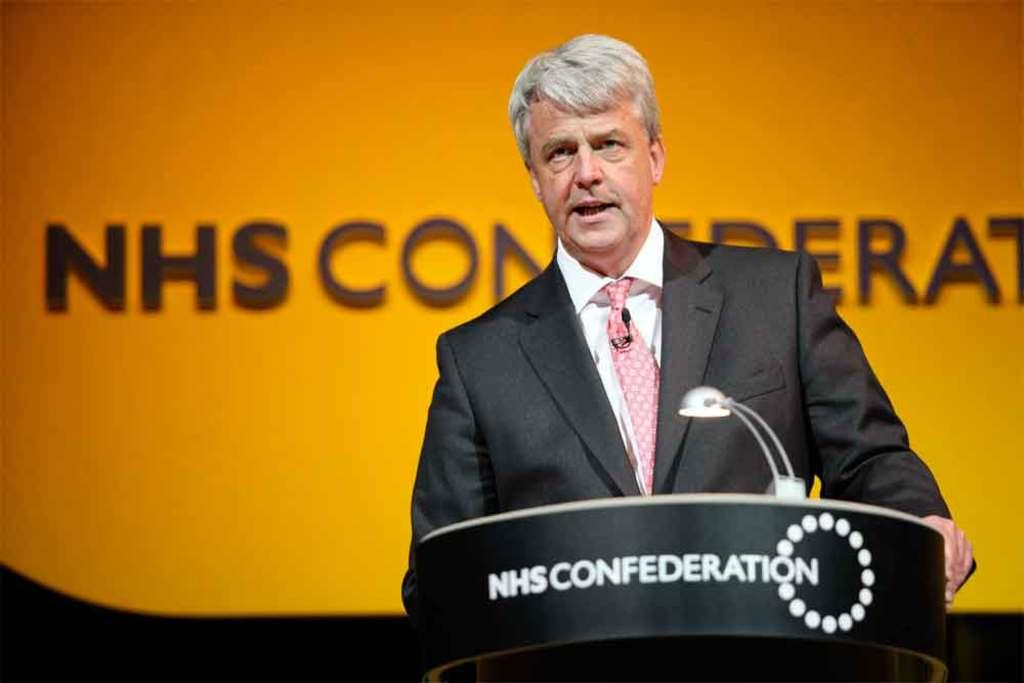Who or what is present in the image? There is a person in the image. Can you describe the person's location in relation to other objects? The person is standing near a table. What object is on the table in the image? There is a torch on the table. What type of grain is being harvested by the person in the image? There is no grain or harvesting activity present in the image; it features a person standing near a table with a torch on it. How many cushions are visible on the table in the image? There are no cushions present in the image; it features a person standing near a table with a torch on it. 